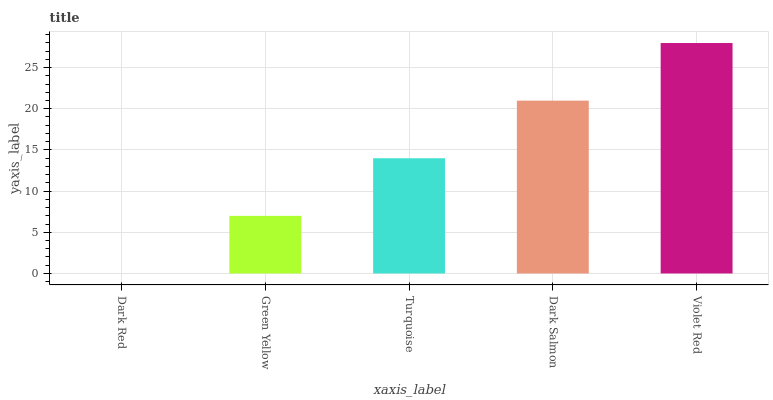Is Dark Red the minimum?
Answer yes or no. Yes. Is Violet Red the maximum?
Answer yes or no. Yes. Is Green Yellow the minimum?
Answer yes or no. No. Is Green Yellow the maximum?
Answer yes or no. No. Is Green Yellow greater than Dark Red?
Answer yes or no. Yes. Is Dark Red less than Green Yellow?
Answer yes or no. Yes. Is Dark Red greater than Green Yellow?
Answer yes or no. No. Is Green Yellow less than Dark Red?
Answer yes or no. No. Is Turquoise the high median?
Answer yes or no. Yes. Is Turquoise the low median?
Answer yes or no. Yes. Is Green Yellow the high median?
Answer yes or no. No. Is Dark Red the low median?
Answer yes or no. No. 